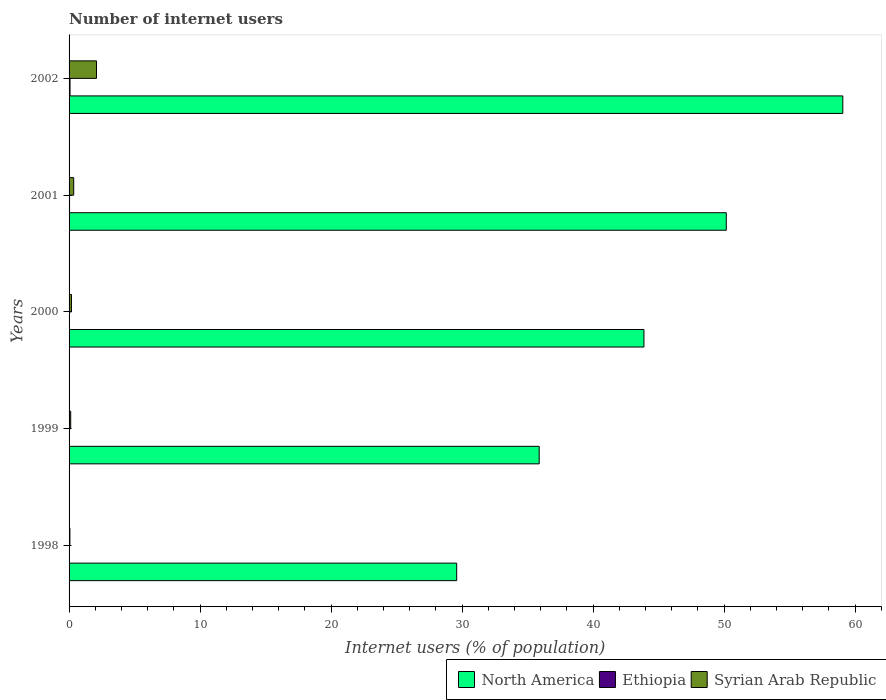How many different coloured bars are there?
Provide a succinct answer. 3. Are the number of bars on each tick of the Y-axis equal?
Provide a succinct answer. Yes. What is the number of internet users in Ethiopia in 1998?
Your answer should be compact. 0.01. Across all years, what is the maximum number of internet users in North America?
Give a very brief answer. 59.06. Across all years, what is the minimum number of internet users in North America?
Provide a succinct answer. 29.59. What is the total number of internet users in Ethiopia in the graph?
Your answer should be very brief. 0.15. What is the difference between the number of internet users in Ethiopia in 1998 and that in 2000?
Offer a very short reply. -0.01. What is the difference between the number of internet users in Ethiopia in 2000 and the number of internet users in Syrian Arab Republic in 1999?
Keep it short and to the point. -0.11. What is the average number of internet users in Syrian Arab Republic per year?
Your response must be concise. 0.56. In the year 2001, what is the difference between the number of internet users in North America and number of internet users in Ethiopia?
Ensure brevity in your answer.  50.12. What is the ratio of the number of internet users in Syrian Arab Republic in 1999 to that in 2002?
Make the answer very short. 0.06. Is the number of internet users in North America in 2000 less than that in 2002?
Your response must be concise. Yes. What is the difference between the highest and the second highest number of internet users in North America?
Ensure brevity in your answer.  8.9. What is the difference between the highest and the lowest number of internet users in Ethiopia?
Ensure brevity in your answer.  0.06. In how many years, is the number of internet users in Syrian Arab Republic greater than the average number of internet users in Syrian Arab Republic taken over all years?
Keep it short and to the point. 1. Is the sum of the number of internet users in Ethiopia in 1999 and 2001 greater than the maximum number of internet users in Syrian Arab Republic across all years?
Your answer should be compact. No. What does the 1st bar from the top in 2001 represents?
Your response must be concise. Syrian Arab Republic. What does the 2nd bar from the bottom in 2000 represents?
Your answer should be compact. Ethiopia. Is it the case that in every year, the sum of the number of internet users in North America and number of internet users in Syrian Arab Republic is greater than the number of internet users in Ethiopia?
Give a very brief answer. Yes. Are all the bars in the graph horizontal?
Offer a very short reply. Yes. What is the difference between two consecutive major ticks on the X-axis?
Provide a short and direct response. 10. How many legend labels are there?
Your answer should be compact. 3. What is the title of the graph?
Your answer should be compact. Number of internet users. What is the label or title of the X-axis?
Provide a succinct answer. Internet users (% of population). What is the Internet users (% of population) in North America in 1998?
Provide a short and direct response. 29.59. What is the Internet users (% of population) in Ethiopia in 1998?
Offer a terse response. 0.01. What is the Internet users (% of population) of Syrian Arab Republic in 1998?
Provide a short and direct response. 0.06. What is the Internet users (% of population) in North America in 1999?
Your response must be concise. 35.88. What is the Internet users (% of population) in Ethiopia in 1999?
Offer a very short reply. 0.01. What is the Internet users (% of population) in Syrian Arab Republic in 1999?
Keep it short and to the point. 0.12. What is the Internet users (% of population) in North America in 2000?
Provide a short and direct response. 43.88. What is the Internet users (% of population) of Ethiopia in 2000?
Ensure brevity in your answer.  0.02. What is the Internet users (% of population) of Syrian Arab Republic in 2000?
Your answer should be compact. 0.18. What is the Internet users (% of population) of North America in 2001?
Give a very brief answer. 50.16. What is the Internet users (% of population) of Ethiopia in 2001?
Ensure brevity in your answer.  0.04. What is the Internet users (% of population) in Syrian Arab Republic in 2001?
Your answer should be compact. 0.35. What is the Internet users (% of population) in North America in 2002?
Offer a very short reply. 59.06. What is the Internet users (% of population) in Ethiopia in 2002?
Make the answer very short. 0.07. What is the Internet users (% of population) in Syrian Arab Republic in 2002?
Your answer should be very brief. 2.09. Across all years, what is the maximum Internet users (% of population) in North America?
Your answer should be compact. 59.06. Across all years, what is the maximum Internet users (% of population) of Ethiopia?
Your answer should be compact. 0.07. Across all years, what is the maximum Internet users (% of population) in Syrian Arab Republic?
Ensure brevity in your answer.  2.09. Across all years, what is the minimum Internet users (% of population) of North America?
Offer a very short reply. 29.59. Across all years, what is the minimum Internet users (% of population) in Ethiopia?
Ensure brevity in your answer.  0.01. Across all years, what is the minimum Internet users (% of population) in Syrian Arab Republic?
Keep it short and to the point. 0.06. What is the total Internet users (% of population) of North America in the graph?
Your answer should be compact. 218.57. What is the total Internet users (% of population) in Ethiopia in the graph?
Your answer should be compact. 0.15. What is the total Internet users (% of population) of Syrian Arab Republic in the graph?
Give a very brief answer. 2.82. What is the difference between the Internet users (% of population) in North America in 1998 and that in 1999?
Your answer should be compact. -6.3. What is the difference between the Internet users (% of population) of Ethiopia in 1998 and that in 1999?
Offer a terse response. -0. What is the difference between the Internet users (% of population) of Syrian Arab Republic in 1998 and that in 1999?
Keep it short and to the point. -0.06. What is the difference between the Internet users (% of population) of North America in 1998 and that in 2000?
Your answer should be very brief. -14.29. What is the difference between the Internet users (% of population) of Ethiopia in 1998 and that in 2000?
Your response must be concise. -0.01. What is the difference between the Internet users (% of population) in Syrian Arab Republic in 1998 and that in 2000?
Make the answer very short. -0.12. What is the difference between the Internet users (% of population) in North America in 1998 and that in 2001?
Your response must be concise. -20.58. What is the difference between the Internet users (% of population) in Ethiopia in 1998 and that in 2001?
Your answer should be very brief. -0.03. What is the difference between the Internet users (% of population) in Syrian Arab Republic in 1998 and that in 2001?
Give a very brief answer. -0.29. What is the difference between the Internet users (% of population) of North America in 1998 and that in 2002?
Offer a very short reply. -29.47. What is the difference between the Internet users (% of population) of Ethiopia in 1998 and that in 2002?
Give a very brief answer. -0.06. What is the difference between the Internet users (% of population) in Syrian Arab Republic in 1998 and that in 2002?
Make the answer very short. -2.03. What is the difference between the Internet users (% of population) of North America in 1999 and that in 2000?
Make the answer very short. -8. What is the difference between the Internet users (% of population) of Ethiopia in 1999 and that in 2000?
Your answer should be very brief. -0. What is the difference between the Internet users (% of population) of Syrian Arab Republic in 1999 and that in 2000?
Provide a short and direct response. -0.06. What is the difference between the Internet users (% of population) in North America in 1999 and that in 2001?
Your response must be concise. -14.28. What is the difference between the Internet users (% of population) in Ethiopia in 1999 and that in 2001?
Give a very brief answer. -0.02. What is the difference between the Internet users (% of population) in Syrian Arab Republic in 1999 and that in 2001?
Your answer should be very brief. -0.23. What is the difference between the Internet users (% of population) of North America in 1999 and that in 2002?
Offer a terse response. -23.17. What is the difference between the Internet users (% of population) of Ethiopia in 1999 and that in 2002?
Make the answer very short. -0.06. What is the difference between the Internet users (% of population) in Syrian Arab Republic in 1999 and that in 2002?
Ensure brevity in your answer.  -1.97. What is the difference between the Internet users (% of population) in North America in 2000 and that in 2001?
Keep it short and to the point. -6.28. What is the difference between the Internet users (% of population) of Ethiopia in 2000 and that in 2001?
Provide a short and direct response. -0.02. What is the difference between the Internet users (% of population) in Syrian Arab Republic in 2000 and that in 2001?
Keep it short and to the point. -0.17. What is the difference between the Internet users (% of population) of North America in 2000 and that in 2002?
Your answer should be very brief. -15.18. What is the difference between the Internet users (% of population) of Ethiopia in 2000 and that in 2002?
Make the answer very short. -0.06. What is the difference between the Internet users (% of population) of Syrian Arab Republic in 2000 and that in 2002?
Provide a succinct answer. -1.91. What is the difference between the Internet users (% of population) of North America in 2001 and that in 2002?
Make the answer very short. -8.9. What is the difference between the Internet users (% of population) of Ethiopia in 2001 and that in 2002?
Make the answer very short. -0.04. What is the difference between the Internet users (% of population) in Syrian Arab Republic in 2001 and that in 2002?
Provide a short and direct response. -1.74. What is the difference between the Internet users (% of population) of North America in 1998 and the Internet users (% of population) of Ethiopia in 1999?
Provide a short and direct response. 29.57. What is the difference between the Internet users (% of population) of North America in 1998 and the Internet users (% of population) of Syrian Arab Republic in 1999?
Offer a terse response. 29.46. What is the difference between the Internet users (% of population) of Ethiopia in 1998 and the Internet users (% of population) of Syrian Arab Republic in 1999?
Ensure brevity in your answer.  -0.11. What is the difference between the Internet users (% of population) of North America in 1998 and the Internet users (% of population) of Ethiopia in 2000?
Make the answer very short. 29.57. What is the difference between the Internet users (% of population) in North America in 1998 and the Internet users (% of population) in Syrian Arab Republic in 2000?
Keep it short and to the point. 29.4. What is the difference between the Internet users (% of population) in Ethiopia in 1998 and the Internet users (% of population) in Syrian Arab Republic in 2000?
Give a very brief answer. -0.17. What is the difference between the Internet users (% of population) of North America in 1998 and the Internet users (% of population) of Ethiopia in 2001?
Make the answer very short. 29.55. What is the difference between the Internet users (% of population) of North America in 1998 and the Internet users (% of population) of Syrian Arab Republic in 2001?
Provide a succinct answer. 29.23. What is the difference between the Internet users (% of population) in Ethiopia in 1998 and the Internet users (% of population) in Syrian Arab Republic in 2001?
Your answer should be very brief. -0.34. What is the difference between the Internet users (% of population) of North America in 1998 and the Internet users (% of population) of Ethiopia in 2002?
Provide a succinct answer. 29.51. What is the difference between the Internet users (% of population) in North America in 1998 and the Internet users (% of population) in Syrian Arab Republic in 2002?
Give a very brief answer. 27.49. What is the difference between the Internet users (% of population) in Ethiopia in 1998 and the Internet users (% of population) in Syrian Arab Republic in 2002?
Provide a short and direct response. -2.08. What is the difference between the Internet users (% of population) of North America in 1999 and the Internet users (% of population) of Ethiopia in 2000?
Make the answer very short. 35.87. What is the difference between the Internet users (% of population) of North America in 1999 and the Internet users (% of population) of Syrian Arab Republic in 2000?
Provide a short and direct response. 35.7. What is the difference between the Internet users (% of population) of Ethiopia in 1999 and the Internet users (% of population) of Syrian Arab Republic in 2000?
Your answer should be compact. -0.17. What is the difference between the Internet users (% of population) of North America in 1999 and the Internet users (% of population) of Ethiopia in 2001?
Your answer should be compact. 35.85. What is the difference between the Internet users (% of population) in North America in 1999 and the Internet users (% of population) in Syrian Arab Republic in 2001?
Your response must be concise. 35.53. What is the difference between the Internet users (% of population) in Ethiopia in 1999 and the Internet users (% of population) in Syrian Arab Republic in 2001?
Your response must be concise. -0.34. What is the difference between the Internet users (% of population) of North America in 1999 and the Internet users (% of population) of Ethiopia in 2002?
Make the answer very short. 35.81. What is the difference between the Internet users (% of population) of North America in 1999 and the Internet users (% of population) of Syrian Arab Republic in 2002?
Provide a succinct answer. 33.79. What is the difference between the Internet users (% of population) in Ethiopia in 1999 and the Internet users (% of population) in Syrian Arab Republic in 2002?
Provide a succinct answer. -2.08. What is the difference between the Internet users (% of population) in North America in 2000 and the Internet users (% of population) in Ethiopia in 2001?
Your answer should be very brief. 43.84. What is the difference between the Internet users (% of population) in North America in 2000 and the Internet users (% of population) in Syrian Arab Republic in 2001?
Provide a succinct answer. 43.53. What is the difference between the Internet users (% of population) in Ethiopia in 2000 and the Internet users (% of population) in Syrian Arab Republic in 2001?
Make the answer very short. -0.34. What is the difference between the Internet users (% of population) of North America in 2000 and the Internet users (% of population) of Ethiopia in 2002?
Provide a succinct answer. 43.81. What is the difference between the Internet users (% of population) in North America in 2000 and the Internet users (% of population) in Syrian Arab Republic in 2002?
Make the answer very short. 41.79. What is the difference between the Internet users (% of population) in Ethiopia in 2000 and the Internet users (% of population) in Syrian Arab Republic in 2002?
Your answer should be compact. -2.08. What is the difference between the Internet users (% of population) of North America in 2001 and the Internet users (% of population) of Ethiopia in 2002?
Offer a terse response. 50.09. What is the difference between the Internet users (% of population) in North America in 2001 and the Internet users (% of population) in Syrian Arab Republic in 2002?
Provide a succinct answer. 48.07. What is the difference between the Internet users (% of population) of Ethiopia in 2001 and the Internet users (% of population) of Syrian Arab Republic in 2002?
Ensure brevity in your answer.  -2.06. What is the average Internet users (% of population) of North America per year?
Make the answer very short. 43.71. What is the average Internet users (% of population) of Ethiopia per year?
Your answer should be very brief. 0.03. What is the average Internet users (% of population) of Syrian Arab Republic per year?
Provide a succinct answer. 0.56. In the year 1998, what is the difference between the Internet users (% of population) of North America and Internet users (% of population) of Ethiopia?
Keep it short and to the point. 29.58. In the year 1998, what is the difference between the Internet users (% of population) of North America and Internet users (% of population) of Syrian Arab Republic?
Provide a succinct answer. 29.52. In the year 1998, what is the difference between the Internet users (% of population) of Ethiopia and Internet users (% of population) of Syrian Arab Republic?
Offer a very short reply. -0.05. In the year 1999, what is the difference between the Internet users (% of population) in North America and Internet users (% of population) in Ethiopia?
Offer a very short reply. 35.87. In the year 1999, what is the difference between the Internet users (% of population) in North America and Internet users (% of population) in Syrian Arab Republic?
Make the answer very short. 35.76. In the year 1999, what is the difference between the Internet users (% of population) of Ethiopia and Internet users (% of population) of Syrian Arab Republic?
Offer a terse response. -0.11. In the year 2000, what is the difference between the Internet users (% of population) of North America and Internet users (% of population) of Ethiopia?
Ensure brevity in your answer.  43.86. In the year 2000, what is the difference between the Internet users (% of population) of North America and Internet users (% of population) of Syrian Arab Republic?
Offer a terse response. 43.7. In the year 2000, what is the difference between the Internet users (% of population) of Ethiopia and Internet users (% of population) of Syrian Arab Republic?
Your response must be concise. -0.17. In the year 2001, what is the difference between the Internet users (% of population) of North America and Internet users (% of population) of Ethiopia?
Offer a terse response. 50.12. In the year 2001, what is the difference between the Internet users (% of population) of North America and Internet users (% of population) of Syrian Arab Republic?
Your response must be concise. 49.81. In the year 2001, what is the difference between the Internet users (% of population) of Ethiopia and Internet users (% of population) of Syrian Arab Republic?
Your answer should be compact. -0.32. In the year 2002, what is the difference between the Internet users (% of population) of North America and Internet users (% of population) of Ethiopia?
Ensure brevity in your answer.  58.98. In the year 2002, what is the difference between the Internet users (% of population) in North America and Internet users (% of population) in Syrian Arab Republic?
Give a very brief answer. 56.96. In the year 2002, what is the difference between the Internet users (% of population) in Ethiopia and Internet users (% of population) in Syrian Arab Republic?
Keep it short and to the point. -2.02. What is the ratio of the Internet users (% of population) of North America in 1998 to that in 1999?
Your answer should be compact. 0.82. What is the ratio of the Internet users (% of population) in Ethiopia in 1998 to that in 1999?
Provide a succinct answer. 0.77. What is the ratio of the Internet users (% of population) of Syrian Arab Republic in 1998 to that in 1999?
Offer a very short reply. 0.51. What is the ratio of the Internet users (% of population) in North America in 1998 to that in 2000?
Make the answer very short. 0.67. What is the ratio of the Internet users (% of population) in Ethiopia in 1998 to that in 2000?
Provide a succinct answer. 0.63. What is the ratio of the Internet users (% of population) in Syrian Arab Republic in 1998 to that in 2000?
Provide a short and direct response. 0.35. What is the ratio of the Internet users (% of population) in North America in 1998 to that in 2001?
Your answer should be compact. 0.59. What is the ratio of the Internet users (% of population) in Ethiopia in 1998 to that in 2001?
Your answer should be very brief. 0.26. What is the ratio of the Internet users (% of population) of Syrian Arab Republic in 1998 to that in 2001?
Your answer should be compact. 0.18. What is the ratio of the Internet users (% of population) of North America in 1998 to that in 2002?
Give a very brief answer. 0.5. What is the ratio of the Internet users (% of population) of Ethiopia in 1998 to that in 2002?
Your answer should be very brief. 0.13. What is the ratio of the Internet users (% of population) in Syrian Arab Republic in 1998 to that in 2002?
Your answer should be very brief. 0.03. What is the ratio of the Internet users (% of population) in North America in 1999 to that in 2000?
Keep it short and to the point. 0.82. What is the ratio of the Internet users (% of population) of Ethiopia in 1999 to that in 2000?
Provide a succinct answer. 0.82. What is the ratio of the Internet users (% of population) of Syrian Arab Republic in 1999 to that in 2000?
Your answer should be compact. 0.68. What is the ratio of the Internet users (% of population) of North America in 1999 to that in 2001?
Your answer should be compact. 0.72. What is the ratio of the Internet users (% of population) in Ethiopia in 1999 to that in 2001?
Offer a very short reply. 0.34. What is the ratio of the Internet users (% of population) in Syrian Arab Republic in 1999 to that in 2001?
Offer a terse response. 0.35. What is the ratio of the Internet users (% of population) of North America in 1999 to that in 2002?
Offer a terse response. 0.61. What is the ratio of the Internet users (% of population) of Ethiopia in 1999 to that in 2002?
Give a very brief answer. 0.17. What is the ratio of the Internet users (% of population) of Syrian Arab Republic in 1999 to that in 2002?
Ensure brevity in your answer.  0.06. What is the ratio of the Internet users (% of population) in North America in 2000 to that in 2001?
Your response must be concise. 0.87. What is the ratio of the Internet users (% of population) in Ethiopia in 2000 to that in 2001?
Your answer should be very brief. 0.41. What is the ratio of the Internet users (% of population) in Syrian Arab Republic in 2000 to that in 2001?
Offer a terse response. 0.51. What is the ratio of the Internet users (% of population) of North America in 2000 to that in 2002?
Give a very brief answer. 0.74. What is the ratio of the Internet users (% of population) of Ethiopia in 2000 to that in 2002?
Give a very brief answer. 0.21. What is the ratio of the Internet users (% of population) of Syrian Arab Republic in 2000 to that in 2002?
Keep it short and to the point. 0.09. What is the ratio of the Internet users (% of population) in North America in 2001 to that in 2002?
Make the answer very short. 0.85. What is the ratio of the Internet users (% of population) of Ethiopia in 2001 to that in 2002?
Provide a succinct answer. 0.51. What is the ratio of the Internet users (% of population) of Syrian Arab Republic in 2001 to that in 2002?
Provide a succinct answer. 0.17. What is the difference between the highest and the second highest Internet users (% of population) of North America?
Provide a succinct answer. 8.9. What is the difference between the highest and the second highest Internet users (% of population) of Ethiopia?
Provide a succinct answer. 0.04. What is the difference between the highest and the second highest Internet users (% of population) of Syrian Arab Republic?
Give a very brief answer. 1.74. What is the difference between the highest and the lowest Internet users (% of population) in North America?
Ensure brevity in your answer.  29.47. What is the difference between the highest and the lowest Internet users (% of population) in Ethiopia?
Keep it short and to the point. 0.06. What is the difference between the highest and the lowest Internet users (% of population) in Syrian Arab Republic?
Give a very brief answer. 2.03. 